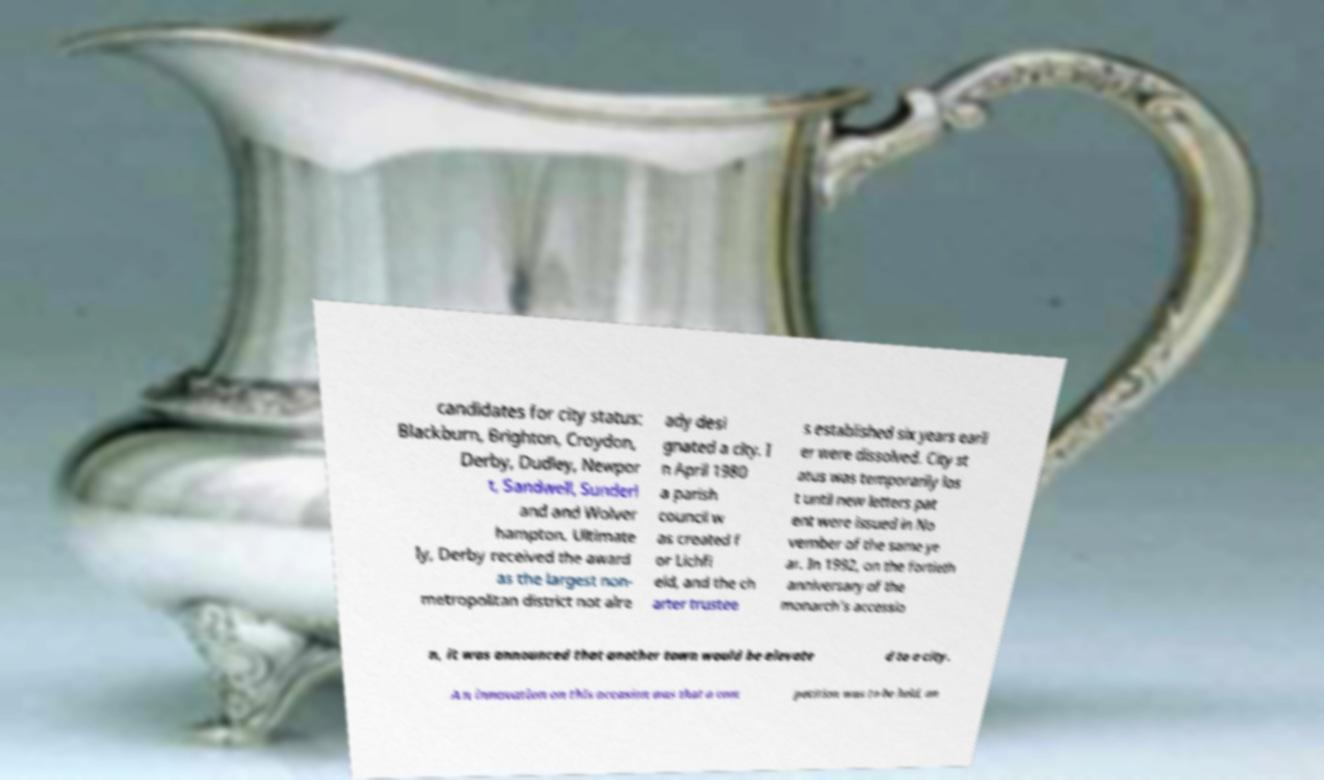Please identify and transcribe the text found in this image. candidates for city status: Blackburn, Brighton, Croydon, Derby, Dudley, Newpor t, Sandwell, Sunderl and and Wolver hampton. Ultimate ly, Derby received the award as the largest non- metropolitan district not alre ady desi gnated a city. I n April 1980 a parish council w as created f or Lichfi eld, and the ch arter trustee s established six years earli er were dissolved. City st atus was temporarily los t until new letters pat ent were issued in No vember of the same ye ar. In 1992, on the fortieth anniversary of the monarch's accessio n, it was announced that another town would be elevate d to a city. An innovation on this occasion was that a com petition was to be held, an 